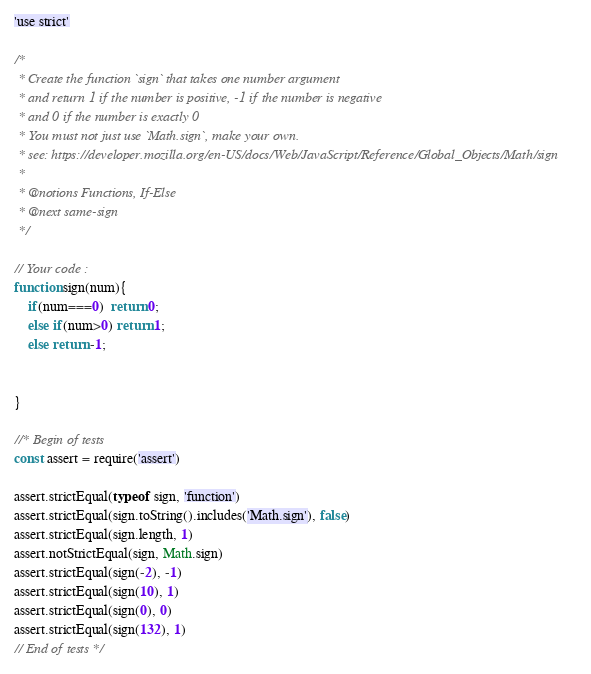<code> <loc_0><loc_0><loc_500><loc_500><_JavaScript_>'use strict'

/*
 * Create the function `sign` that takes one number argument
 * and return 1 if the number is positive, -1 if the number is negative
 * and 0 if the number is exactly 0
 * You must not just use `Math.sign`, make your own.
 * see: https://developer.mozilla.org/en-US/docs/Web/JavaScript/Reference/Global_Objects/Math/sign
 *
 * @notions Functions, If-Else
 * @next same-sign
 */

// Your code :
function sign(num){
    if(num===0)  return 0;
    else if(num>0) return 1;
    else return -1;
        
    
}

//* Begin of tests
const assert = require('assert')

assert.strictEqual(typeof sign, 'function')
assert.strictEqual(sign.toString().includes('Math.sign'), false)
assert.strictEqual(sign.length, 1)
assert.notStrictEqual(sign, Math.sign)
assert.strictEqual(sign(-2), -1)
assert.strictEqual(sign(10), 1)
assert.strictEqual(sign(0), 0)
assert.strictEqual(sign(132), 1)
// End of tests */
</code> 